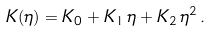<formula> <loc_0><loc_0><loc_500><loc_500>K ( \eta ) = K _ { 0 } + K _ { 1 } \, \eta + K _ { 2 } \, \eta ^ { 2 } \, .</formula> 